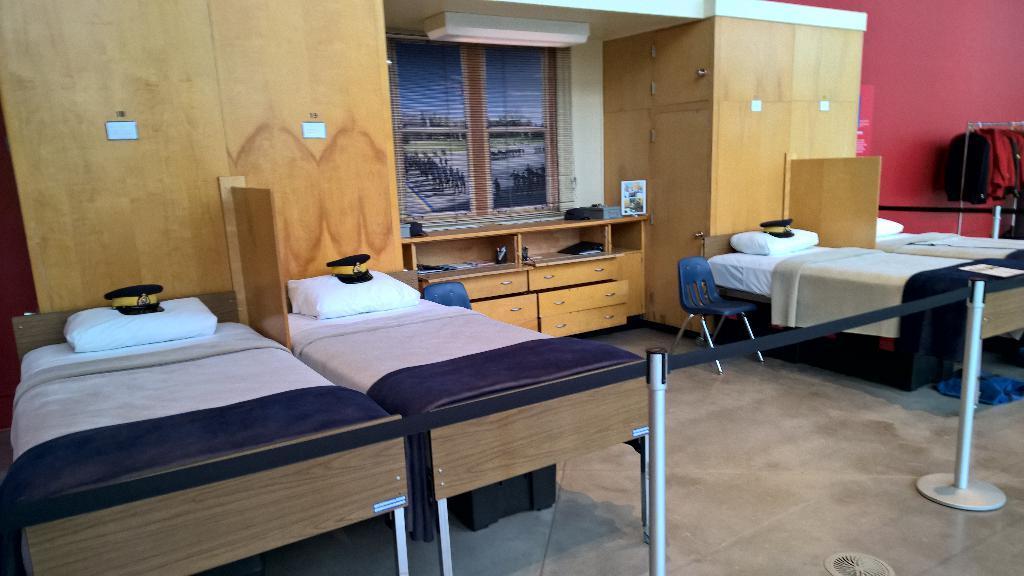Can you describe this image briefly? In this image i can see i can see four beds, four pillows, two chairs, at the back ground i can see a cup board, a window. 